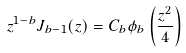Convert formula to latex. <formula><loc_0><loc_0><loc_500><loc_500>z ^ { 1 - b } J _ { b - 1 } ( z ) = C _ { b } \phi _ { b } \left ( \frac { z ^ { 2 } } { 4 } \right )</formula> 